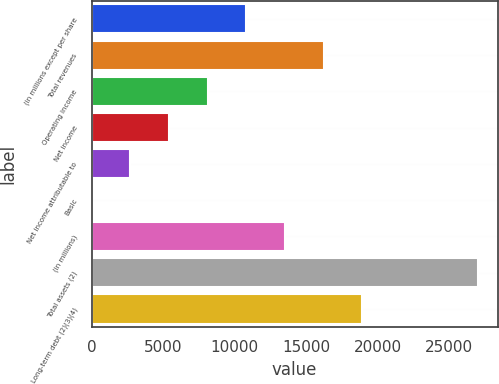<chart> <loc_0><loc_0><loc_500><loc_500><bar_chart><fcel>(in millions except per share<fcel>Total revenues<fcel>Operating income<fcel>Net income<fcel>Net income attributable to<fcel>Basic<fcel>(in millions)<fcel>Total assets (2)<fcel>Long-term debt (2)(3)(4)<nl><fcel>10817.9<fcel>16226.2<fcel>8113.7<fcel>5409.52<fcel>2705.34<fcel>1.15<fcel>13522.1<fcel>27043<fcel>18930.4<nl></chart> 